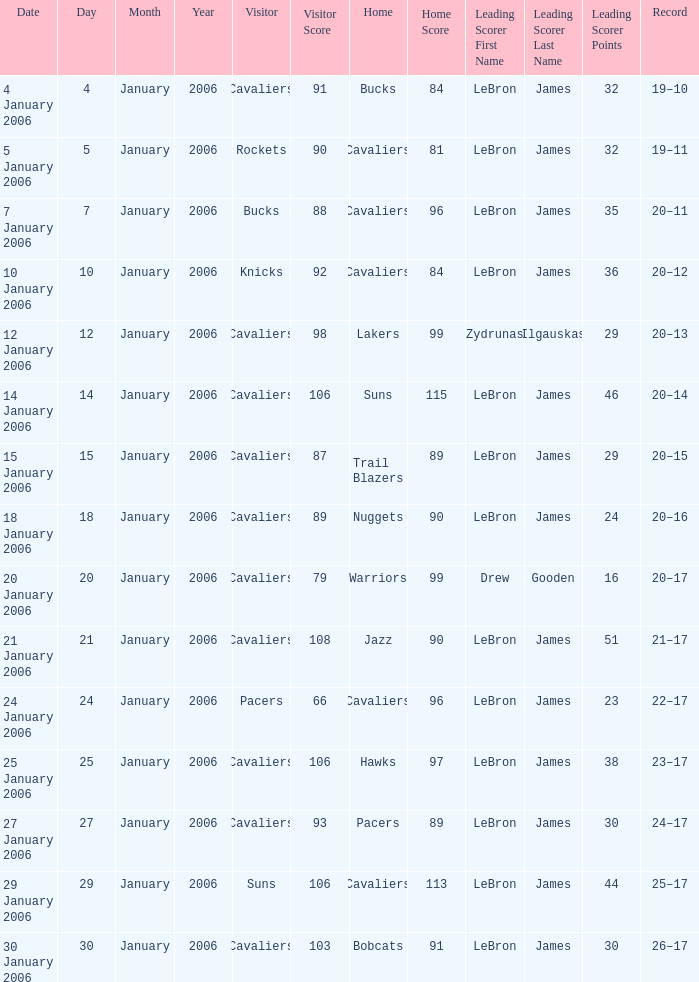Who was the leading score in the game at the Warriors? Drew Gooden (16). 